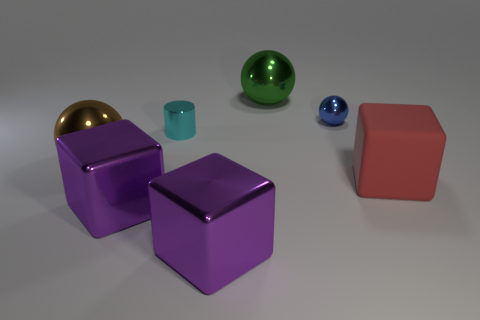The large red matte thing has what shape?
Make the answer very short. Cube. How many things are cyan things or metallic things that are in front of the cyan metallic cylinder?
Give a very brief answer. 4. Does the small metal thing to the right of the cyan shiny cylinder have the same color as the big rubber block?
Your response must be concise. No. What color is the big metal object that is both on the left side of the small cyan thing and in front of the big brown shiny thing?
Ensure brevity in your answer.  Purple. What is the large thing that is on the right side of the large green object made of?
Ensure brevity in your answer.  Rubber. The brown shiny thing is what size?
Provide a succinct answer. Large. How many gray things are either big shiny blocks or large blocks?
Provide a short and direct response. 0. There is a purple object left of the big purple object that is to the right of the cyan metal object; how big is it?
Your answer should be compact. Large. Is the color of the small metallic sphere the same as the metallic ball that is behind the tiny ball?
Your response must be concise. No. How many other objects are there of the same material as the green sphere?
Give a very brief answer. 5. 